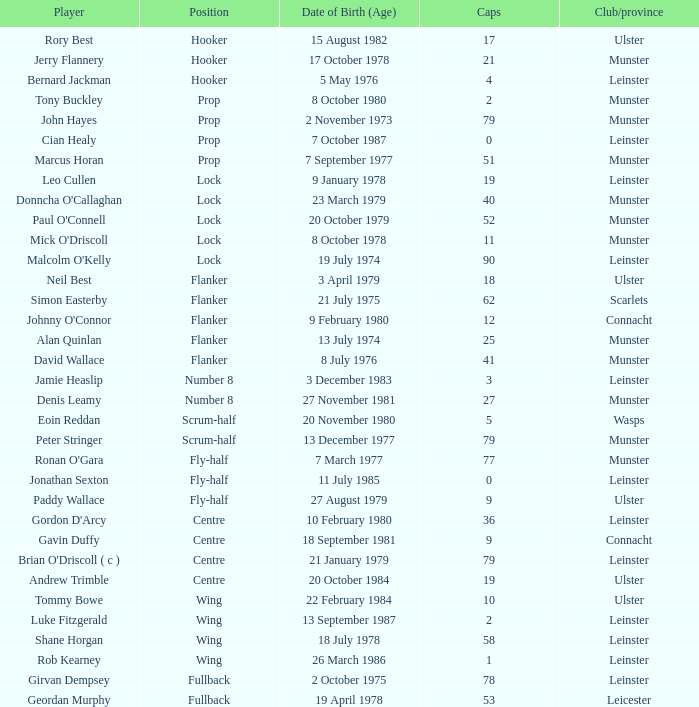What Club/province have caps less than 2 and Jonathan Sexton as player? Leinster. 